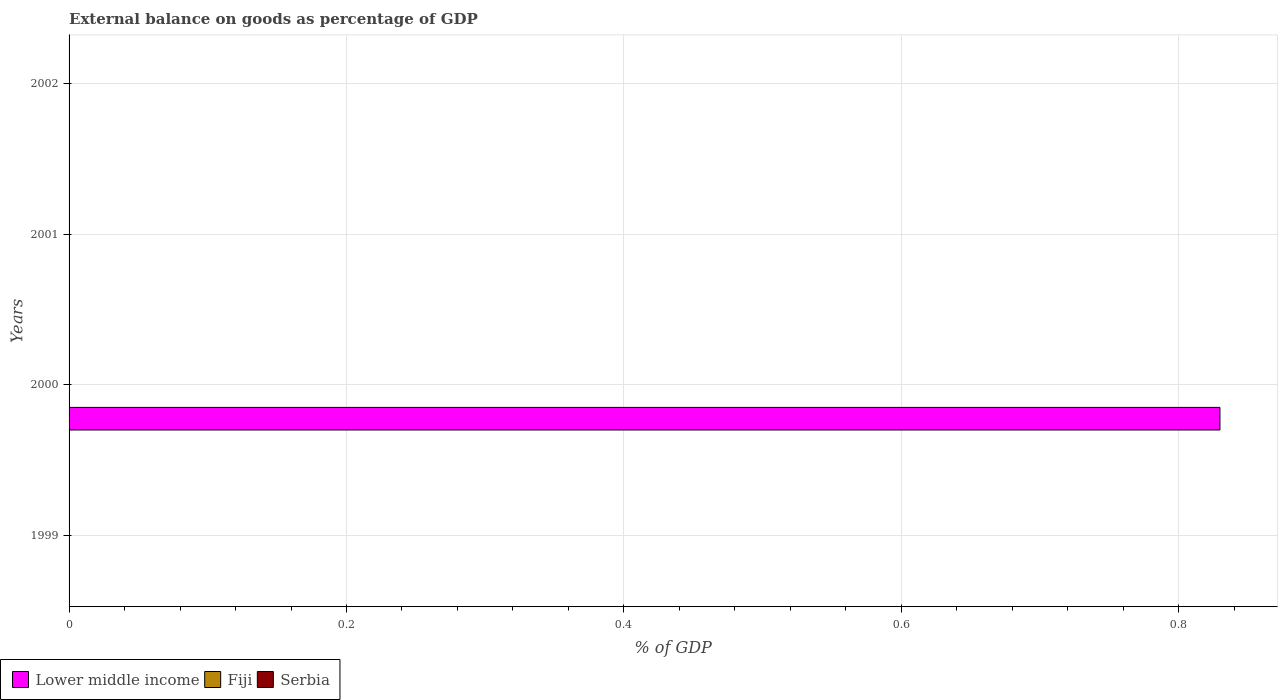In how many cases, is the number of bars for a given year not equal to the number of legend labels?
Make the answer very short. 4. What is the external balance on goods as percentage of GDP in Serbia in 2000?
Offer a terse response. 0. Across all years, what is the maximum external balance on goods as percentage of GDP in Lower middle income?
Your answer should be very brief. 0.83. In which year was the external balance on goods as percentage of GDP in Lower middle income maximum?
Your response must be concise. 2000. What is the average external balance on goods as percentage of GDP in Lower middle income per year?
Ensure brevity in your answer.  0.21. In how many years, is the external balance on goods as percentage of GDP in Serbia greater than 0.24000000000000002 %?
Offer a very short reply. 0. What is the difference between the highest and the lowest external balance on goods as percentage of GDP in Lower middle income?
Provide a short and direct response. 0.83. In how many years, is the external balance on goods as percentage of GDP in Lower middle income greater than the average external balance on goods as percentage of GDP in Lower middle income taken over all years?
Provide a short and direct response. 1. Is it the case that in every year, the sum of the external balance on goods as percentage of GDP in Fiji and external balance on goods as percentage of GDP in Serbia is greater than the external balance on goods as percentage of GDP in Lower middle income?
Make the answer very short. No. How many bars are there?
Provide a succinct answer. 1. Are all the bars in the graph horizontal?
Provide a short and direct response. Yes. How many years are there in the graph?
Give a very brief answer. 4. What is the difference between two consecutive major ticks on the X-axis?
Ensure brevity in your answer.  0.2. Does the graph contain grids?
Provide a succinct answer. Yes. How many legend labels are there?
Offer a very short reply. 3. What is the title of the graph?
Your answer should be compact. External balance on goods as percentage of GDP. Does "Curacao" appear as one of the legend labels in the graph?
Ensure brevity in your answer.  No. What is the label or title of the X-axis?
Ensure brevity in your answer.  % of GDP. What is the label or title of the Y-axis?
Give a very brief answer. Years. What is the % of GDP in Fiji in 1999?
Provide a short and direct response. 0. What is the % of GDP in Lower middle income in 2000?
Your answer should be very brief. 0.83. What is the % of GDP of Serbia in 2000?
Offer a very short reply. 0. What is the % of GDP in Lower middle income in 2001?
Provide a short and direct response. 0. What is the % of GDP in Fiji in 2001?
Your answer should be compact. 0. What is the % of GDP of Serbia in 2002?
Keep it short and to the point. 0. Across all years, what is the maximum % of GDP of Lower middle income?
Keep it short and to the point. 0.83. Across all years, what is the minimum % of GDP in Lower middle income?
Give a very brief answer. 0. What is the total % of GDP in Lower middle income in the graph?
Provide a short and direct response. 0.83. What is the total % of GDP in Fiji in the graph?
Your response must be concise. 0. What is the total % of GDP of Serbia in the graph?
Provide a short and direct response. 0. What is the average % of GDP in Lower middle income per year?
Provide a succinct answer. 0.21. What is the average % of GDP in Serbia per year?
Your answer should be very brief. 0. What is the difference between the highest and the lowest % of GDP in Lower middle income?
Provide a short and direct response. 0.83. 